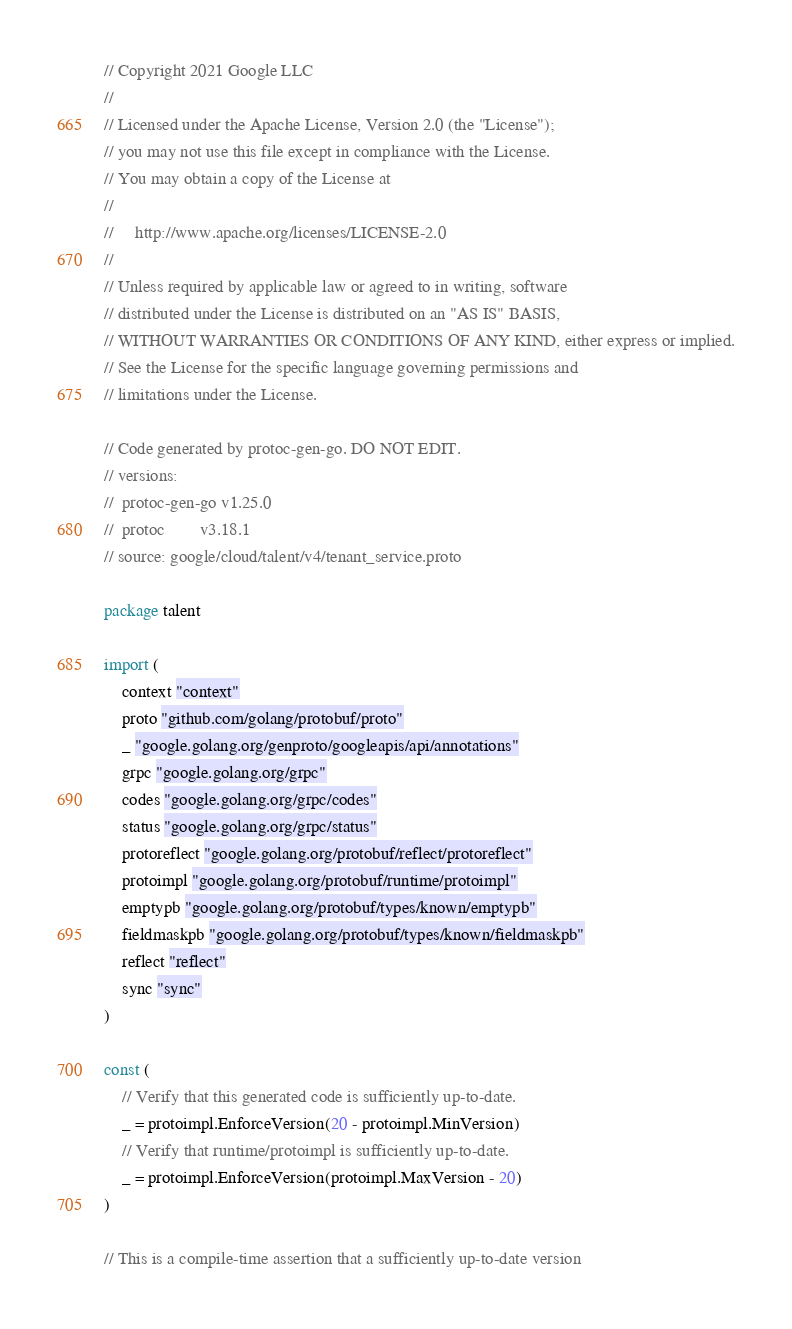<code> <loc_0><loc_0><loc_500><loc_500><_Go_>// Copyright 2021 Google LLC
//
// Licensed under the Apache License, Version 2.0 (the "License");
// you may not use this file except in compliance with the License.
// You may obtain a copy of the License at
//
//     http://www.apache.org/licenses/LICENSE-2.0
//
// Unless required by applicable law or agreed to in writing, software
// distributed under the License is distributed on an "AS IS" BASIS,
// WITHOUT WARRANTIES OR CONDITIONS OF ANY KIND, either express or implied.
// See the License for the specific language governing permissions and
// limitations under the License.

// Code generated by protoc-gen-go. DO NOT EDIT.
// versions:
// 	protoc-gen-go v1.25.0
// 	protoc        v3.18.1
// source: google/cloud/talent/v4/tenant_service.proto

package talent

import (
	context "context"
	proto "github.com/golang/protobuf/proto"
	_ "google.golang.org/genproto/googleapis/api/annotations"
	grpc "google.golang.org/grpc"
	codes "google.golang.org/grpc/codes"
	status "google.golang.org/grpc/status"
	protoreflect "google.golang.org/protobuf/reflect/protoreflect"
	protoimpl "google.golang.org/protobuf/runtime/protoimpl"
	emptypb "google.golang.org/protobuf/types/known/emptypb"
	fieldmaskpb "google.golang.org/protobuf/types/known/fieldmaskpb"
	reflect "reflect"
	sync "sync"
)

const (
	// Verify that this generated code is sufficiently up-to-date.
	_ = protoimpl.EnforceVersion(20 - protoimpl.MinVersion)
	// Verify that runtime/protoimpl is sufficiently up-to-date.
	_ = protoimpl.EnforceVersion(protoimpl.MaxVersion - 20)
)

// This is a compile-time assertion that a sufficiently up-to-date version</code> 